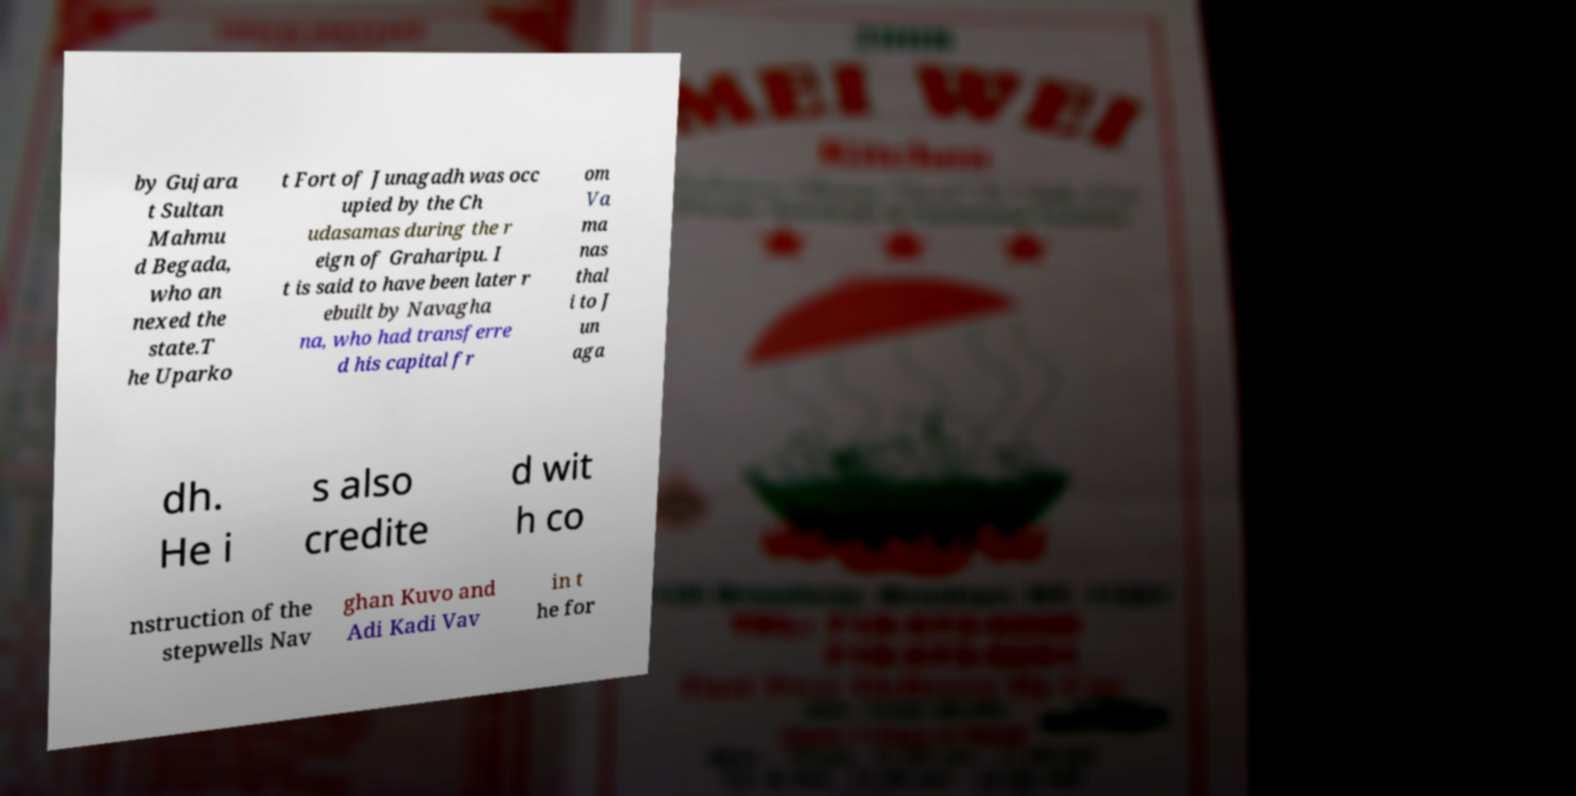Can you accurately transcribe the text from the provided image for me? by Gujara t Sultan Mahmu d Begada, who an nexed the state.T he Uparko t Fort of Junagadh was occ upied by the Ch udasamas during the r eign of Graharipu. I t is said to have been later r ebuilt by Navagha na, who had transferre d his capital fr om Va ma nas thal i to J un aga dh. He i s also credite d wit h co nstruction of the stepwells Nav ghan Kuvo and Adi Kadi Vav in t he for 